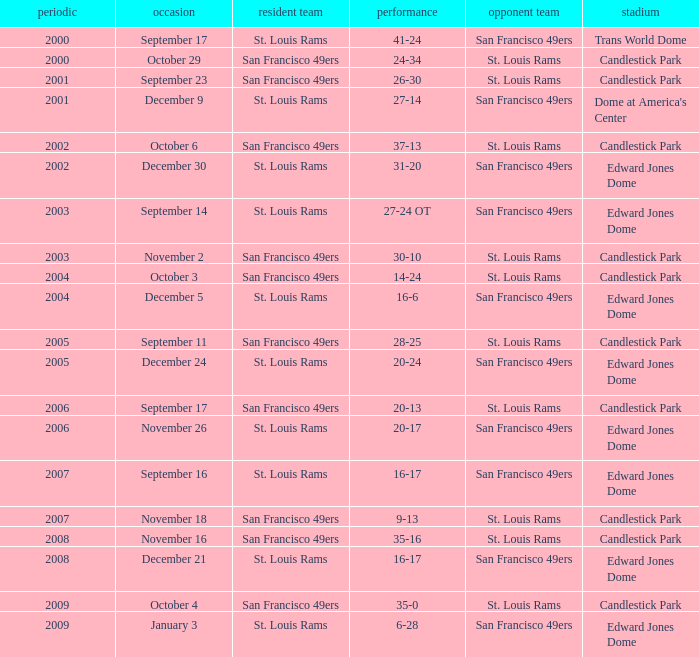What was the Venue on November 26? Edward Jones Dome. 